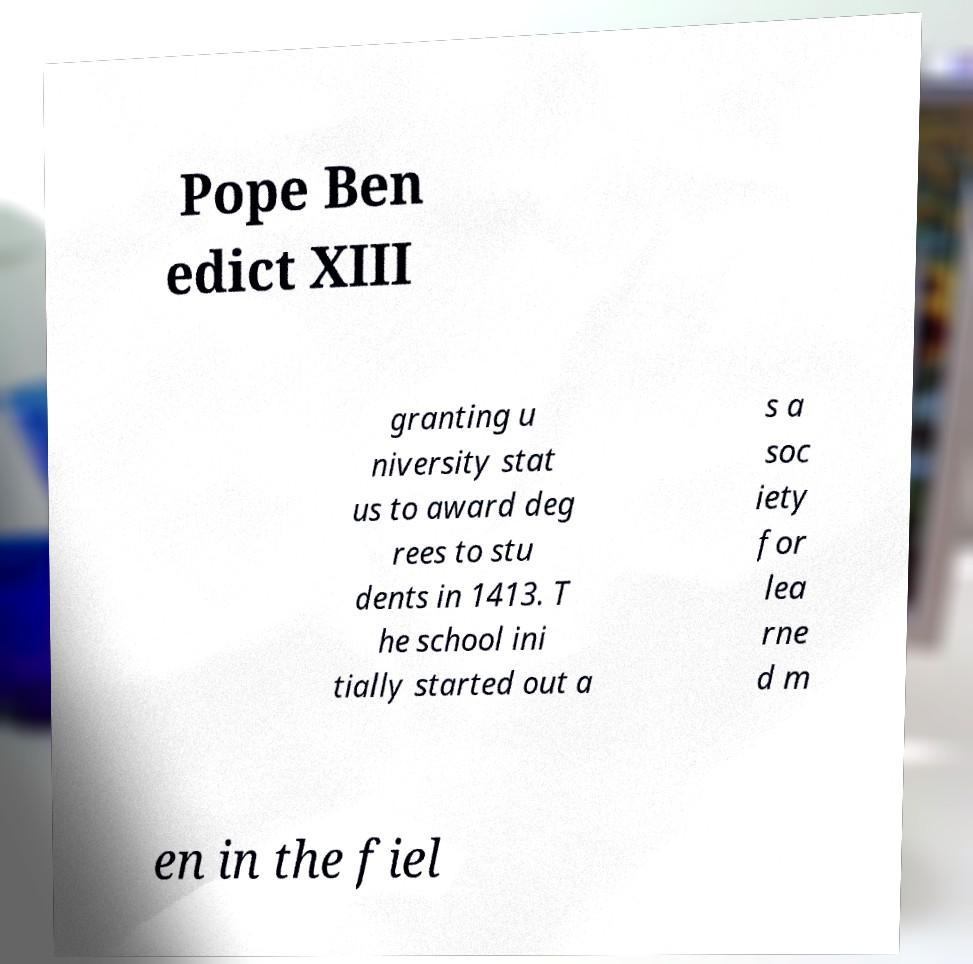Please read and relay the text visible in this image. What does it say? Pope Ben edict XIII granting u niversity stat us to award deg rees to stu dents in 1413. T he school ini tially started out a s a soc iety for lea rne d m en in the fiel 